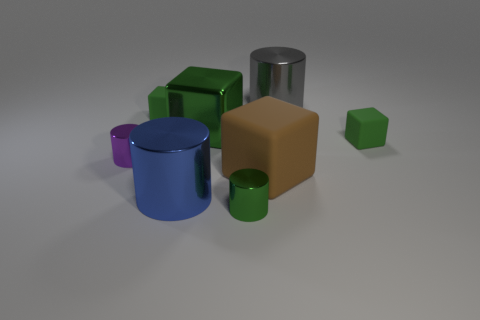What number of large gray cylinders are in front of the tiny shiny cylinder right of the small purple shiny thing?
Your response must be concise. 0. What number of other things are there of the same size as the blue metal cylinder?
Provide a short and direct response. 3. What is the size of the metallic object that is the same color as the large metallic cube?
Provide a short and direct response. Small. Does the large metal thing that is to the left of the big green shiny thing have the same shape as the gray shiny thing?
Ensure brevity in your answer.  Yes. What material is the small block to the right of the brown cube?
Offer a very short reply. Rubber. There is a tiny metallic object that is the same color as the metal block; what shape is it?
Offer a very short reply. Cylinder. Is there another purple cylinder that has the same material as the small purple cylinder?
Offer a very short reply. No. What size is the purple shiny cylinder?
Provide a succinct answer. Small. What number of blue objects are rubber objects or large things?
Your answer should be very brief. 1. What number of other things have the same shape as the big blue object?
Your answer should be very brief. 3. 